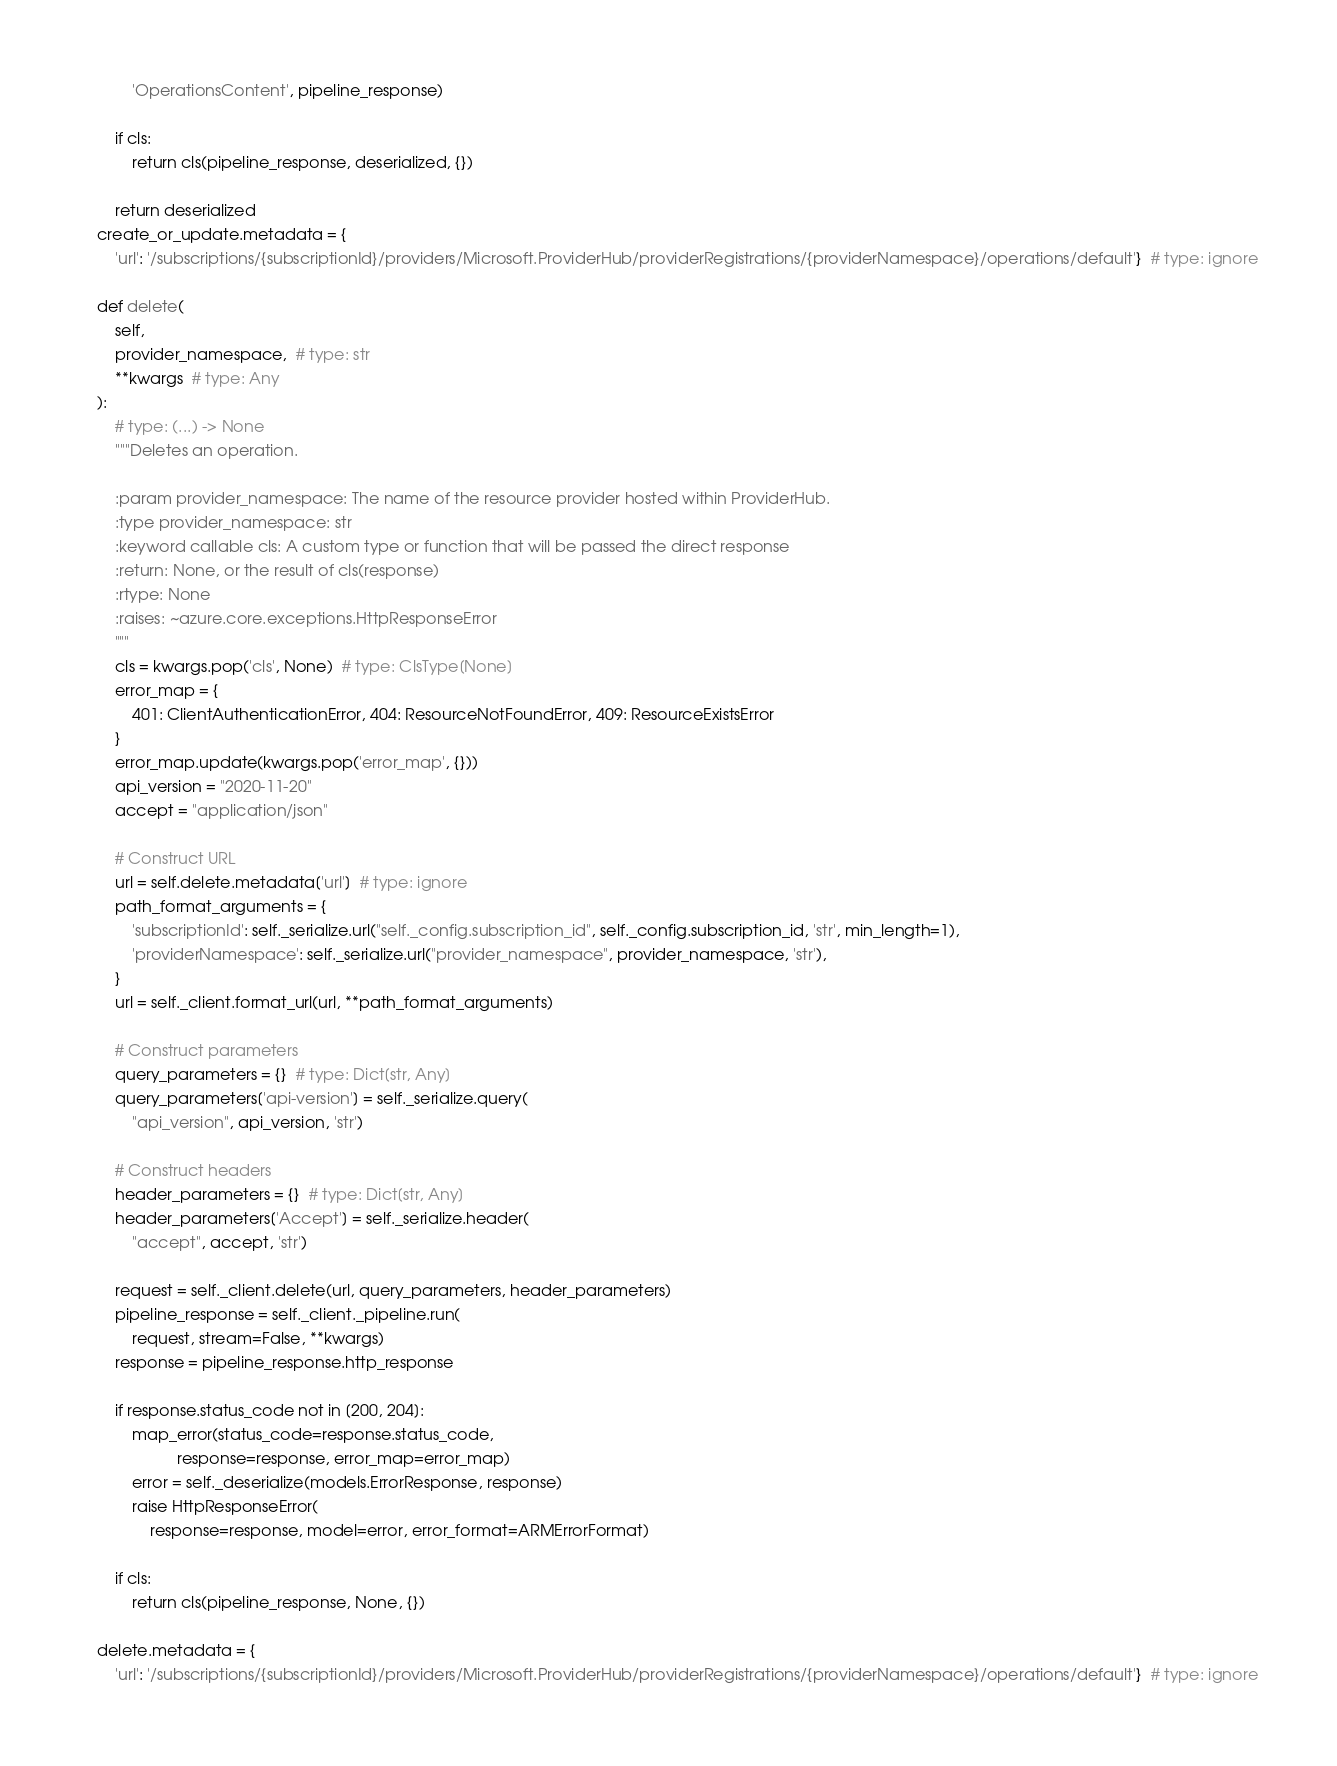Convert code to text. <code><loc_0><loc_0><loc_500><loc_500><_Python_>            'OperationsContent', pipeline_response)

        if cls:
            return cls(pipeline_response, deserialized, {})

        return deserialized
    create_or_update.metadata = {
        'url': '/subscriptions/{subscriptionId}/providers/Microsoft.ProviderHub/providerRegistrations/{providerNamespace}/operations/default'}  # type: ignore

    def delete(
        self,
        provider_namespace,  # type: str
        **kwargs  # type: Any
    ):
        # type: (...) -> None
        """Deletes an operation.

        :param provider_namespace: The name of the resource provider hosted within ProviderHub.
        :type provider_namespace: str
        :keyword callable cls: A custom type or function that will be passed the direct response
        :return: None, or the result of cls(response)
        :rtype: None
        :raises: ~azure.core.exceptions.HttpResponseError
        """
        cls = kwargs.pop('cls', None)  # type: ClsType[None]
        error_map = {
            401: ClientAuthenticationError, 404: ResourceNotFoundError, 409: ResourceExistsError
        }
        error_map.update(kwargs.pop('error_map', {}))
        api_version = "2020-11-20"
        accept = "application/json"

        # Construct URL
        url = self.delete.metadata['url']  # type: ignore
        path_format_arguments = {
            'subscriptionId': self._serialize.url("self._config.subscription_id", self._config.subscription_id, 'str', min_length=1),
            'providerNamespace': self._serialize.url("provider_namespace", provider_namespace, 'str'),
        }
        url = self._client.format_url(url, **path_format_arguments)

        # Construct parameters
        query_parameters = {}  # type: Dict[str, Any]
        query_parameters['api-version'] = self._serialize.query(
            "api_version", api_version, 'str')

        # Construct headers
        header_parameters = {}  # type: Dict[str, Any]
        header_parameters['Accept'] = self._serialize.header(
            "accept", accept, 'str')

        request = self._client.delete(url, query_parameters, header_parameters)
        pipeline_response = self._client._pipeline.run(
            request, stream=False, **kwargs)
        response = pipeline_response.http_response

        if response.status_code not in [200, 204]:
            map_error(status_code=response.status_code,
                      response=response, error_map=error_map)
            error = self._deserialize(models.ErrorResponse, response)
            raise HttpResponseError(
                response=response, model=error, error_format=ARMErrorFormat)

        if cls:
            return cls(pipeline_response, None, {})

    delete.metadata = {
        'url': '/subscriptions/{subscriptionId}/providers/Microsoft.ProviderHub/providerRegistrations/{providerNamespace}/operations/default'}  # type: ignore
</code> 